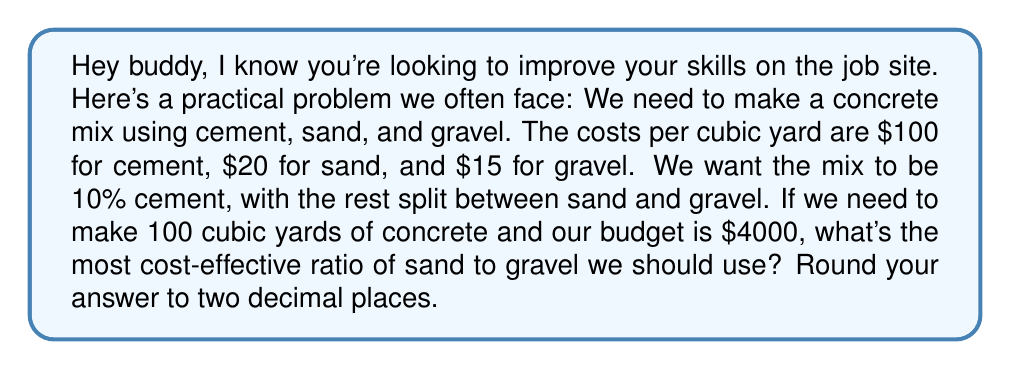Give your solution to this math problem. Alright, let's break this down step-by-step:

1) First, let's define our variables:
   $x$ = cubic yards of sand
   $y$ = cubic yards of gravel

2) We know the total volume is 100 cubic yards, and 10% is cement. So:
   $x + y = 90$ (since 90% is sand and gravel)

3) Now, let's set up our cost equation:
   $100(10) + 20x + 15y \leq 4000$
   (cement cost) + (sand cost) + (gravel cost) ≤ total budget

4) Simplify:
   $1000 + 20x + 15y \leq 4000$
   $20x + 15y \leq 3000$

5) We want to maximize $x + y$ (to get as much material as possible) while satisfying these constraints. This is a linear programming problem.

6) Solve the equation from step 2 for $y$:
   $y = 90 - x$

7) Substitute this into the inequality from step 4:
   $20x + 15(90 - x) \leq 3000$
   $20x + 1350 - 15x \leq 3000$
   $5x + 1350 \leq 3000$
   $5x \leq 1650$
   $x \leq 330$

8) The maximum value for $x$ is 330. So:
   $x = 330$
   $y = 90 - 330 = -240$ (which is impossible)

9) The actual maximum values that satisfy both constraints are:
   $x = 90$
   $y = 0$

10) Therefore, the most cost-effective ratio of sand to gravel is 90:0, or simplified, 1:0.
Answer: The most cost-effective ratio of sand to gravel is 1:0. 